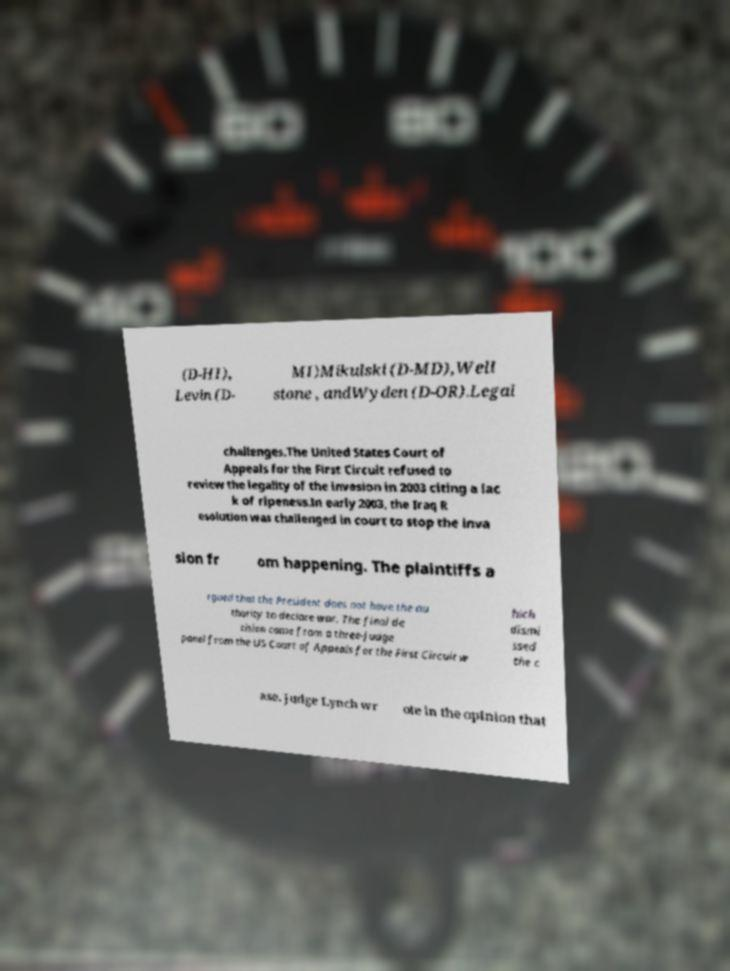For documentation purposes, I need the text within this image transcribed. Could you provide that? (D-HI), Levin (D- MI)Mikulski (D-MD),Well stone , andWyden (D-OR).Legal challenges.The United States Court of Appeals for the First Circuit refused to review the legality of the invasion in 2003 citing a lac k of ripeness.In early 2003, the Iraq R esolution was challenged in court to stop the inva sion fr om happening. The plaintiffs a rgued that the President does not have the au thority to declare war. The final de cision came from a three-judge panel from the US Court of Appeals for the First Circuit w hich dismi ssed the c ase. Judge Lynch wr ote in the opinion that 